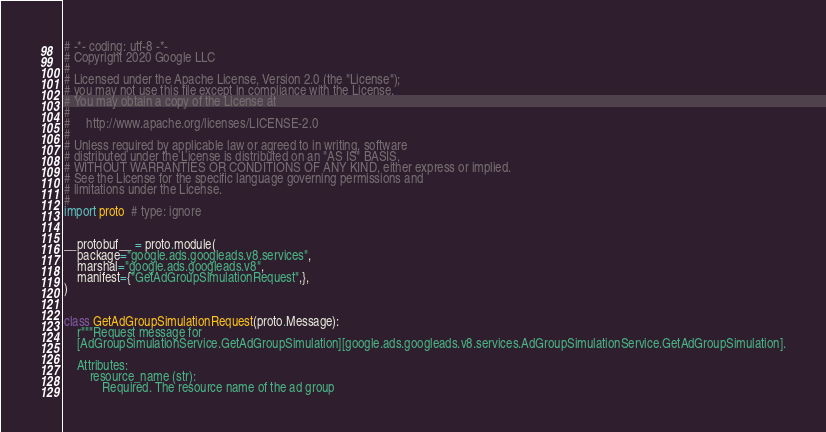<code> <loc_0><loc_0><loc_500><loc_500><_Python_># -*- coding: utf-8 -*-
# Copyright 2020 Google LLC
#
# Licensed under the Apache License, Version 2.0 (the "License");
# you may not use this file except in compliance with the License.
# You may obtain a copy of the License at
#
#     http://www.apache.org/licenses/LICENSE-2.0
#
# Unless required by applicable law or agreed to in writing, software
# distributed under the License is distributed on an "AS IS" BASIS,
# WITHOUT WARRANTIES OR CONDITIONS OF ANY KIND, either express or implied.
# See the License for the specific language governing permissions and
# limitations under the License.
#
import proto  # type: ignore


__protobuf__ = proto.module(
    package="google.ads.googleads.v8.services",
    marshal="google.ads.googleads.v8",
    manifest={"GetAdGroupSimulationRequest",},
)


class GetAdGroupSimulationRequest(proto.Message):
    r"""Request message for
    [AdGroupSimulationService.GetAdGroupSimulation][google.ads.googleads.v8.services.AdGroupSimulationService.GetAdGroupSimulation].

    Attributes:
        resource_name (str):
            Required. The resource name of the ad group</code> 